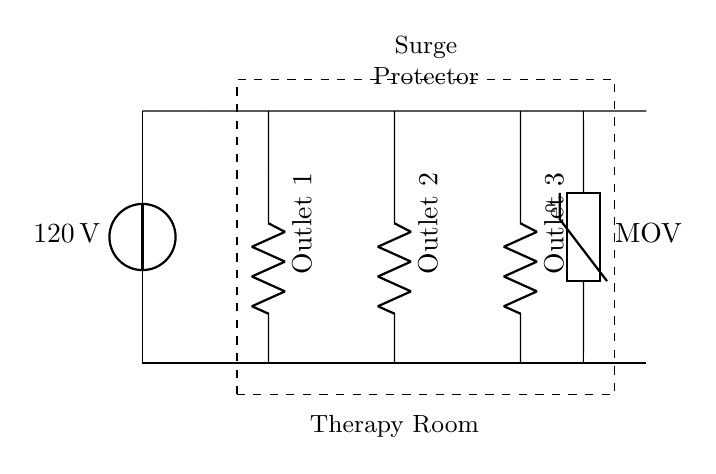What is the voltage of this circuit? The voltage is 120 volts, which is indicated next to the voltage source in the diagram.
Answer: 120 volts What components are in the surge protector? The components are the multiple outlets and a Metal Oxide Varistor (MOV) for surge protection. These components are shown within a dashed rectangle labeled 'Surge Protector.'
Answer: Multiple outlets and MOV How many outlets are present in the therapy room? There are three outlets in the circuit diagram, as labeled Outlet 1, Outlet 2, and Outlet 3.
Answer: Three What is the purpose of the Metal Oxide Varistor in the circuit? The MOV protects against voltage spikes by clamping excessive voltage to prevent damage to the connected devices. It is shown connected to the main line and the ground line.
Answer: Surge protection Do the outlets operate in series or parallel? The outlets operate in parallel, as they are connected across the same voltage source and each outlet has its own independent connection to the source.
Answer: Parallel What is the configuration of the connections to the outlets? The outlets are each connected to the main line individually, allowing them to operate independently. This means that if one outlet fails, the others will continue to function.
Answer: Independent connections 